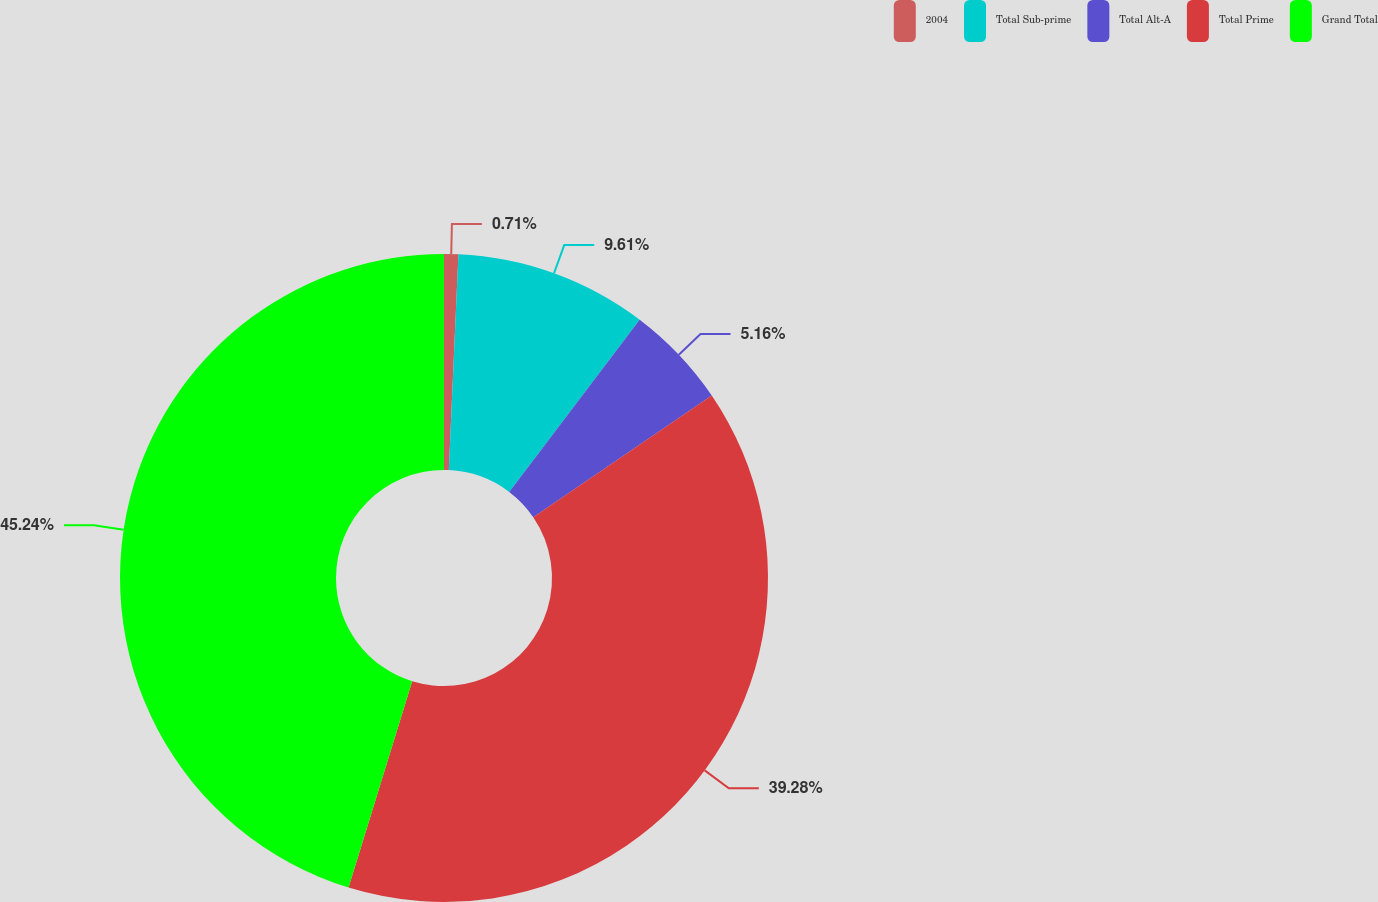Convert chart to OTSL. <chart><loc_0><loc_0><loc_500><loc_500><pie_chart><fcel>2004<fcel>Total Sub-prime<fcel>Total Alt-A<fcel>Total Prime<fcel>Grand Total<nl><fcel>0.71%<fcel>9.61%<fcel>5.16%<fcel>39.28%<fcel>45.24%<nl></chart> 